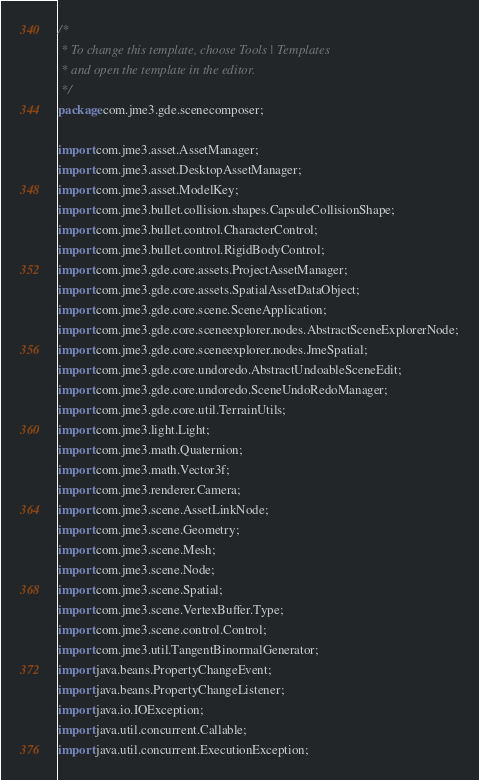Convert code to text. <code><loc_0><loc_0><loc_500><loc_500><_Java_>/*
 * To change this template, choose Tools | Templates
 * and open the template in the editor.
 */
package com.jme3.gde.scenecomposer;

import com.jme3.asset.AssetManager;
import com.jme3.asset.DesktopAssetManager;
import com.jme3.asset.ModelKey;
import com.jme3.bullet.collision.shapes.CapsuleCollisionShape;
import com.jme3.bullet.control.CharacterControl;
import com.jme3.bullet.control.RigidBodyControl;
import com.jme3.gde.core.assets.ProjectAssetManager;
import com.jme3.gde.core.assets.SpatialAssetDataObject;
import com.jme3.gde.core.scene.SceneApplication;
import com.jme3.gde.core.sceneexplorer.nodes.AbstractSceneExplorerNode;
import com.jme3.gde.core.sceneexplorer.nodes.JmeSpatial;
import com.jme3.gde.core.undoredo.AbstractUndoableSceneEdit;
import com.jme3.gde.core.undoredo.SceneUndoRedoManager;
import com.jme3.gde.core.util.TerrainUtils;
import com.jme3.light.Light;
import com.jme3.math.Quaternion;
import com.jme3.math.Vector3f;
import com.jme3.renderer.Camera;
import com.jme3.scene.AssetLinkNode;
import com.jme3.scene.Geometry;
import com.jme3.scene.Mesh;
import com.jme3.scene.Node;
import com.jme3.scene.Spatial;
import com.jme3.scene.VertexBuffer.Type;
import com.jme3.scene.control.Control;
import com.jme3.util.TangentBinormalGenerator;
import java.beans.PropertyChangeEvent;
import java.beans.PropertyChangeListener;
import java.io.IOException;
import java.util.concurrent.Callable;
import java.util.concurrent.ExecutionException;</code> 